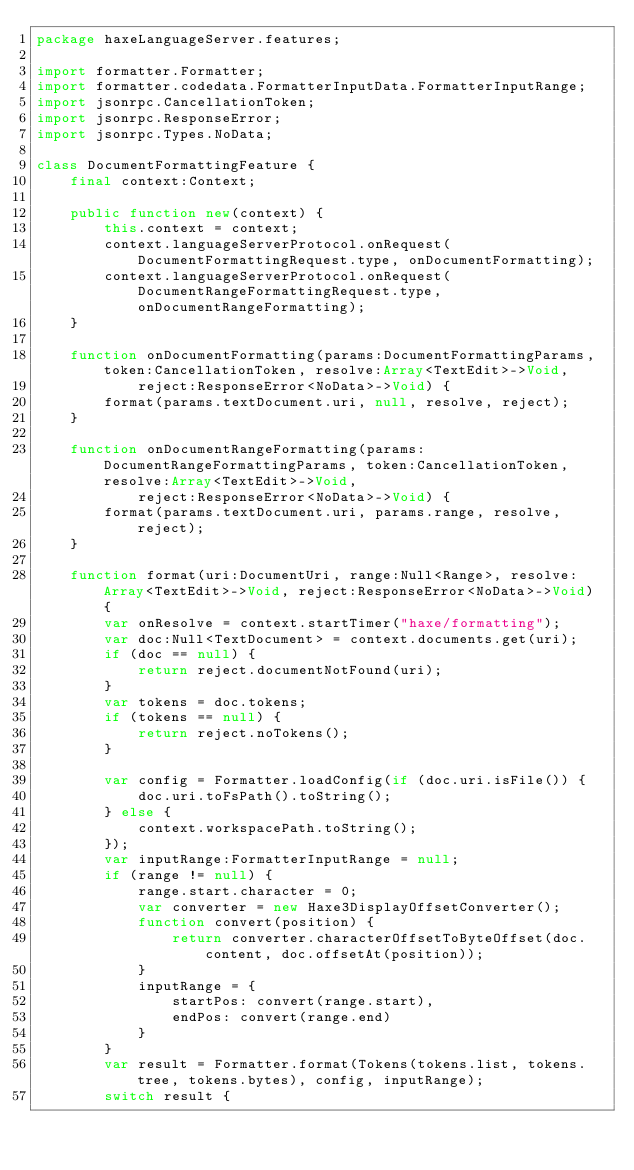Convert code to text. <code><loc_0><loc_0><loc_500><loc_500><_Haxe_>package haxeLanguageServer.features;

import formatter.Formatter;
import formatter.codedata.FormatterInputData.FormatterInputRange;
import jsonrpc.CancellationToken;
import jsonrpc.ResponseError;
import jsonrpc.Types.NoData;

class DocumentFormattingFeature {
	final context:Context;

	public function new(context) {
		this.context = context;
		context.languageServerProtocol.onRequest(DocumentFormattingRequest.type, onDocumentFormatting);
		context.languageServerProtocol.onRequest(DocumentRangeFormattingRequest.type, onDocumentRangeFormatting);
	}

	function onDocumentFormatting(params:DocumentFormattingParams, token:CancellationToken, resolve:Array<TextEdit>->Void,
			reject:ResponseError<NoData>->Void) {
		format(params.textDocument.uri, null, resolve, reject);
	}

	function onDocumentRangeFormatting(params:DocumentRangeFormattingParams, token:CancellationToken, resolve:Array<TextEdit>->Void,
			reject:ResponseError<NoData>->Void) {
		format(params.textDocument.uri, params.range, resolve, reject);
	}

	function format(uri:DocumentUri, range:Null<Range>, resolve:Array<TextEdit>->Void, reject:ResponseError<NoData>->Void) {
		var onResolve = context.startTimer("haxe/formatting");
		var doc:Null<TextDocument> = context.documents.get(uri);
		if (doc == null) {
			return reject.documentNotFound(uri);
		}
		var tokens = doc.tokens;
		if (tokens == null) {
			return reject.noTokens();
		}

		var config = Formatter.loadConfig(if (doc.uri.isFile()) {
			doc.uri.toFsPath().toString();
		} else {
			context.workspacePath.toString();
		});
		var inputRange:FormatterInputRange = null;
		if (range != null) {
			range.start.character = 0;
			var converter = new Haxe3DisplayOffsetConverter();
			function convert(position) {
				return converter.characterOffsetToByteOffset(doc.content, doc.offsetAt(position));
			}
			inputRange = {
				startPos: convert(range.start),
				endPos: convert(range.end)
			}
		}
		var result = Formatter.format(Tokens(tokens.list, tokens.tree, tokens.bytes), config, inputRange);
		switch result {</code> 